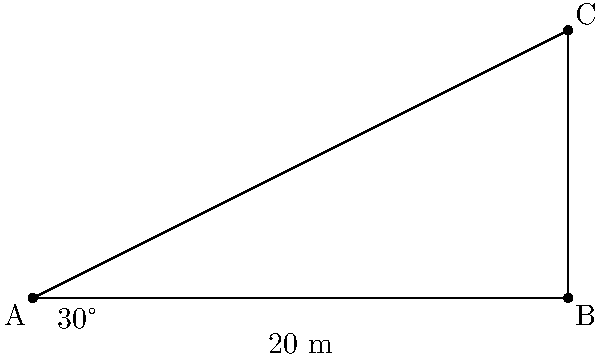A software architect is designing a system to calculate the height of structures using trigonometry. To test the system, they use a flagpole scenario. If the angle of elevation to the top of a flagpole is $30^\circ$ when measured from a point 20 meters away from its base, what is the height of the flagpole? Round your answer to the nearest tenth of a meter. Let's approach this step-by-step:

1) First, we identify the trigonometric function that relates the angle of elevation to the height of the flagpole. In this case, it's the tangent function.

2) We can set up the equation:
   $\tan(30^\circ) = \frac{\text{opposite}}{\text{adjacent}} = \frac{\text{height}}{\text{distance}}$

3) We know the distance is 20 meters, so we can write:
   $\tan(30^\circ) = \frac{\text{height}}{20}$

4) To solve for the height, we multiply both sides by 20:
   $20 \cdot \tan(30^\circ) = \text{height}$

5) Now we need to calculate this:
   $\tan(30^\circ) \approx 0.5773502692$

6) Multiplying by 20:
   $20 \cdot 0.5773502692 \approx 11.54700538$ meters

7) Rounding to the nearest tenth:
   $11.5$ meters

This approach demonstrates how trigonometric functions can be used in software applications to solve real-world problems efficiently.
Answer: 11.5 meters 